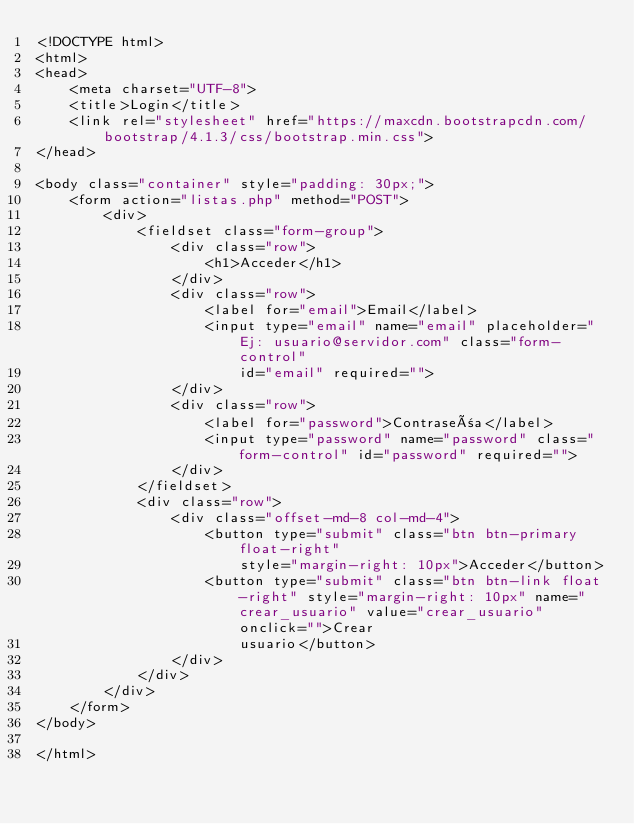<code> <loc_0><loc_0><loc_500><loc_500><_HTML_><!DOCTYPE html>
<html>
<head>
    <meta charset="UTF-8">
    <title>Login</title>
    <link rel="stylesheet" href="https://maxcdn.bootstrapcdn.com/bootstrap/4.1.3/css/bootstrap.min.css">
</head>

<body class="container" style="padding: 30px;">
    <form action="listas.php" method="POST">
        <div>
            <fieldset class="form-group">
                <div class="row">
                    <h1>Acceder</h1>
                </div>
                <div class="row">
                    <label for="email">Email</label>
                    <input type="email" name="email" placeholder="Ej: usuario@servidor.com" class="form-control"
                        id="email" required="">
                </div>
                <div class="row">
                    <label for="password">Contraseña</label>
                    <input type="password" name="password" class="form-control" id="password" required="">
                </div>
            </fieldset>
            <div class="row">
                <div class="offset-md-8 col-md-4">
                    <button type="submit" class="btn btn-primary float-right"
                        style="margin-right: 10px">Acceder</button>
                    <button type="submit" class="btn btn-link float-right" style="margin-right: 10px" name="crear_usuario" value="crear_usuario" onclick="">Crear
                        usuario</button>
                </div>
            </div>
        </div>
    </form>
</body>

</html></code> 